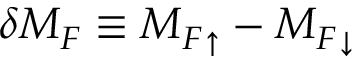Convert formula to latex. <formula><loc_0><loc_0><loc_500><loc_500>\delta M _ { F } \equiv M _ { F } _ { \uparrow } - { M _ { F } } _ { \downarrow }</formula> 